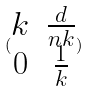Convert formula to latex. <formula><loc_0><loc_0><loc_500><loc_500>( \begin{matrix} k & \frac { d } { n k } \\ 0 & \frac { 1 } { k } \end{matrix} )</formula> 